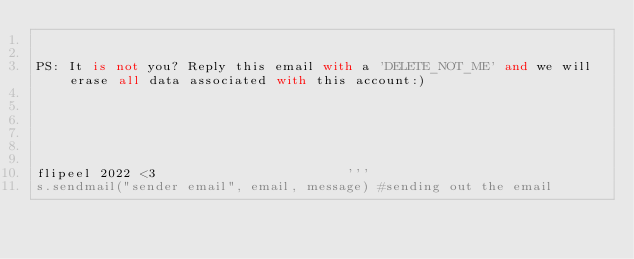<code> <loc_0><loc_0><loc_500><loc_500><_Python_>

PS: It is not you? Reply this email with a 'DELETE_NOT_ME' and we will erase all data associated with this account:) 






flipeel 2022 <3                        '''
s.sendmail("sender email", email, message) #sending out the email</code> 